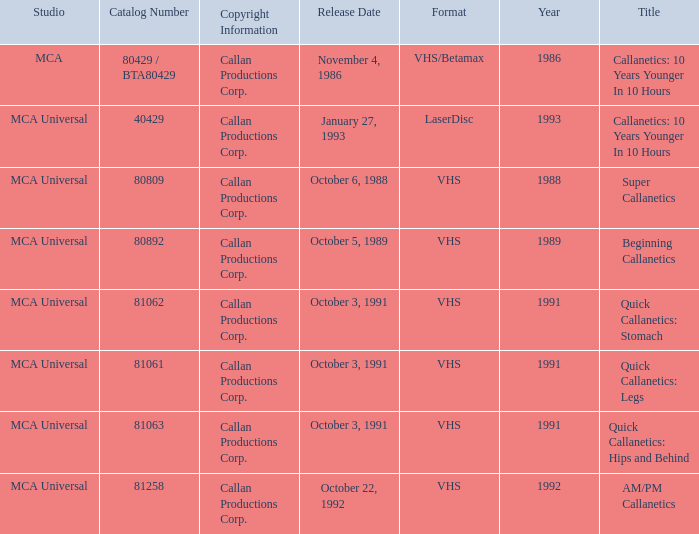Name the catalog number for am/pm callanetics 81258.0. 